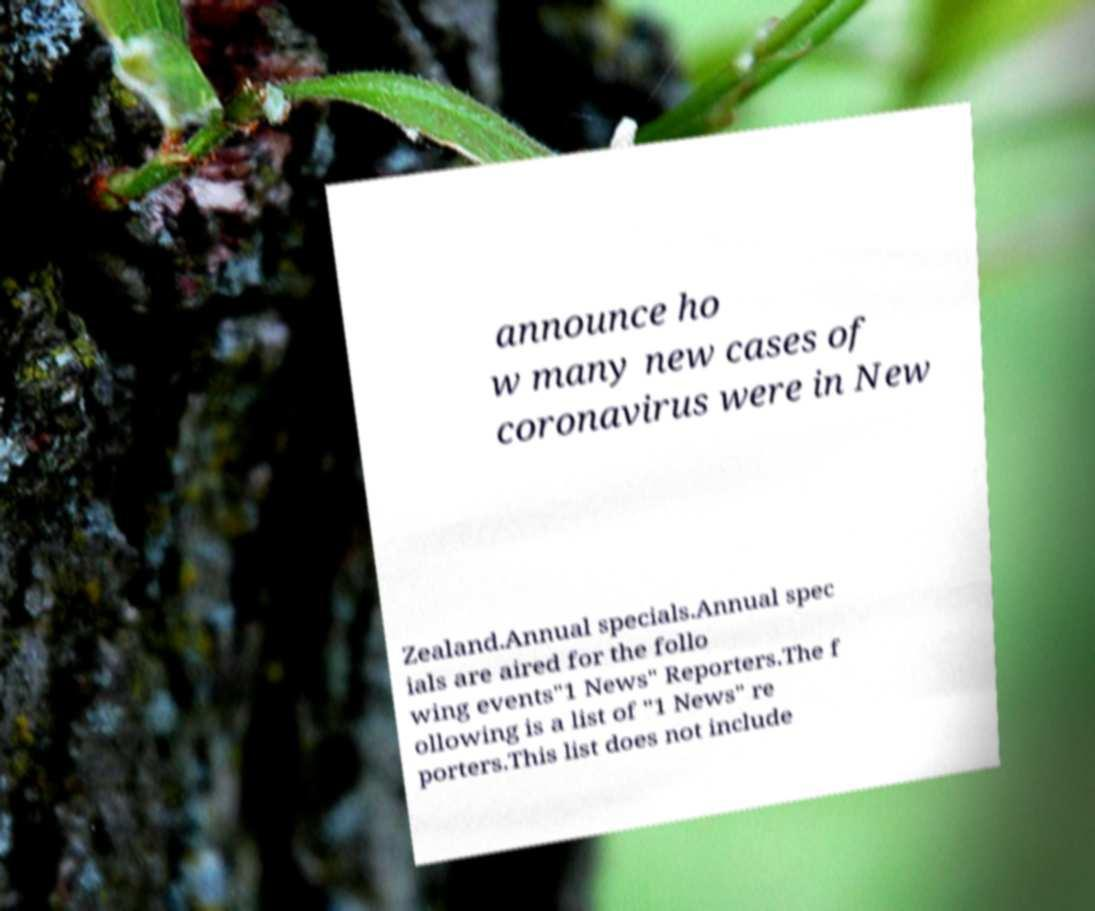What messages or text are displayed in this image? I need them in a readable, typed format. announce ho w many new cases of coronavirus were in New Zealand.Annual specials.Annual spec ials are aired for the follo wing events"1 News" Reporters.The f ollowing is a list of "1 News" re porters.This list does not include 